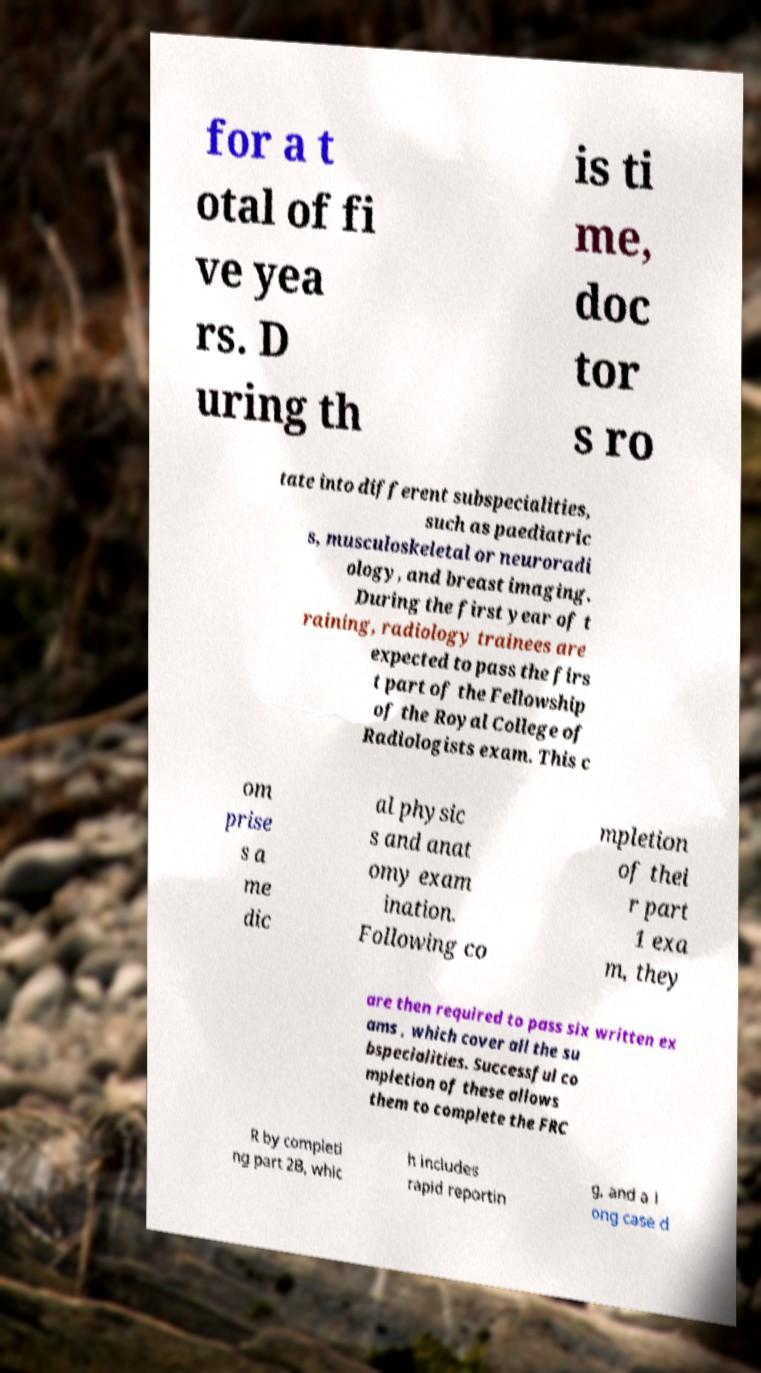I need the written content from this picture converted into text. Can you do that? for a t otal of fi ve yea rs. D uring th is ti me, doc tor s ro tate into different subspecialities, such as paediatric s, musculoskeletal or neuroradi ology, and breast imaging. During the first year of t raining, radiology trainees are expected to pass the firs t part of the Fellowship of the Royal College of Radiologists exam. This c om prise s a me dic al physic s and anat omy exam ination. Following co mpletion of thei r part 1 exa m, they are then required to pass six written ex ams , which cover all the su bspecialities. Successful co mpletion of these allows them to complete the FRC R by completi ng part 2B, whic h includes rapid reportin g, and a l ong case d 